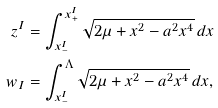<formula> <loc_0><loc_0><loc_500><loc_500>z ^ { I } & = \int _ { x _ { - } ^ { I } } ^ { x _ { + } ^ { I } } \sqrt { 2 \mu + x ^ { 2 } - a ^ { 2 } x ^ { 4 } } \, d x \\ w _ { I } & = \int _ { x _ { - } ^ { I } } ^ { \Lambda } \sqrt { 2 \mu + x ^ { 2 } - a ^ { 2 } x ^ { 4 } } \, d x ,</formula> 